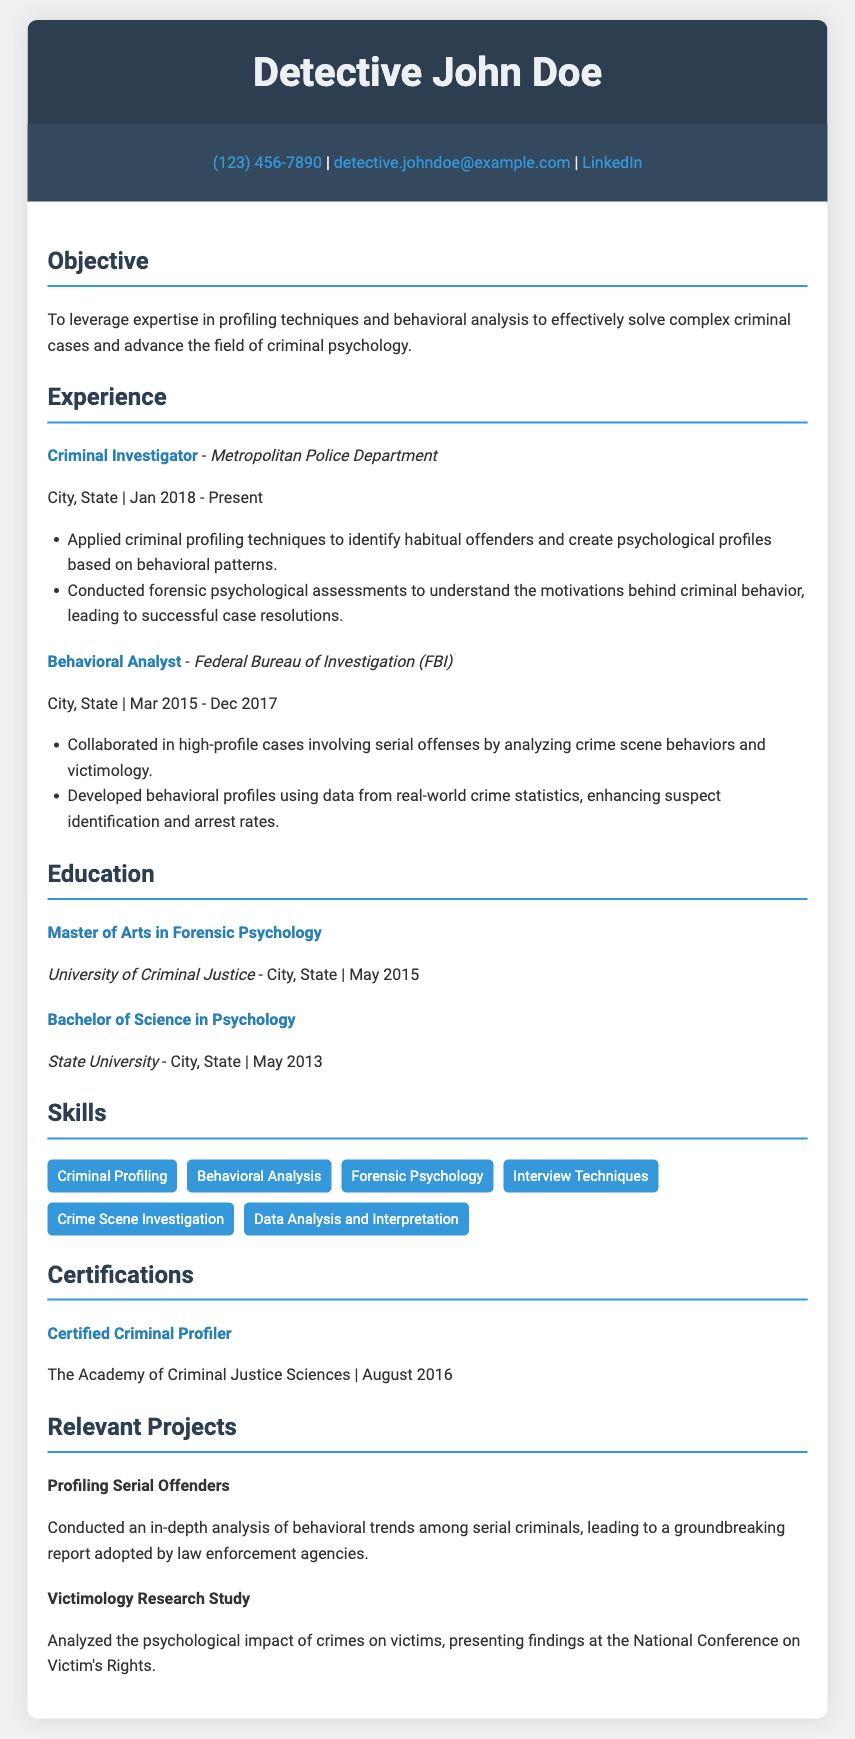What is the name of the detective? The name of the detective is presented at the top of the document under the header section.
Answer: Detective John Doe What is the title of John Doe's current position? The current position is listed in the experience section of the document.
Answer: Criminal Investigator Which department does John Doe work for? The department is specified in the experience section where his title is mentioned.
Answer: Metropolitan Police Department In what year did John Doe obtain his Master's degree? The year is indicated in the education section when listing his Master's degree in Forensic Psychology.
Answer: 2015 What key technique does John Doe specialize in? The skills section highlights several techniques, but this is specifically noted as his specialty.
Answer: Criminal Profiling How many years of experience does John Doe have at the Metropolitan Police Department? The duration of his employment is mentioned in the experience section format as a starting and ending date.
Answer: 5 years What significant project did John Doe conduct? This information is found in the relevant projects section, identifying a specific project he worked on.
Answer: Profiling Serial Offenders Which certification does John Doe hold? The certification section lists the specific certification he has achieved.
Answer: Certified Criminal Profiler From which university did John Doe earn his Bachelor's degree? The institution that awarded the degree is clearly stated in the education section.
Answer: State University 